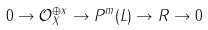Convert formula to latex. <formula><loc_0><loc_0><loc_500><loc_500>0 \to \mathcal { O } _ { X } ^ { \oplus x } \to P ^ { m } ( L ) \to R \to 0</formula> 